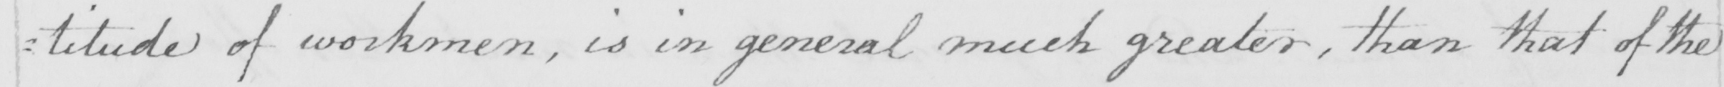What does this handwritten line say? : titude of workmen , is in general much greater , than that of the 